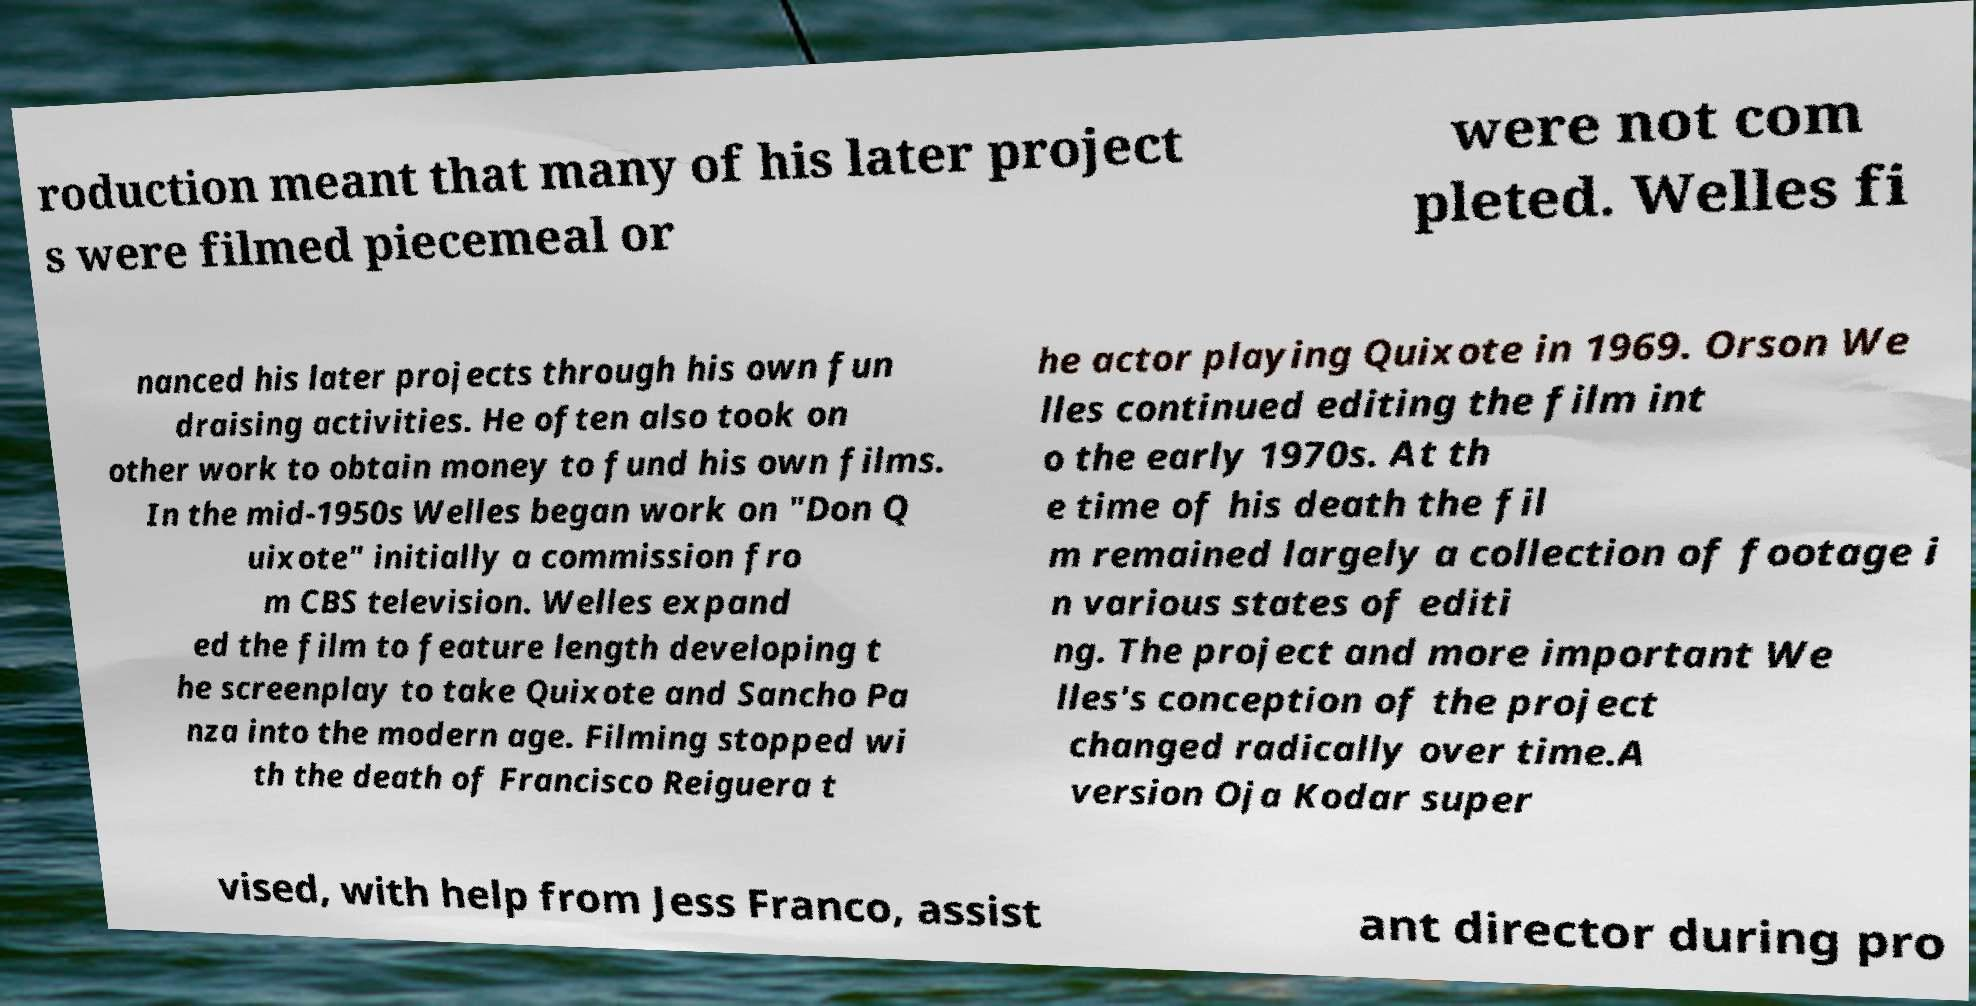Can you read and provide the text displayed in the image?This photo seems to have some interesting text. Can you extract and type it out for me? roduction meant that many of his later project s were filmed piecemeal or were not com pleted. Welles fi nanced his later projects through his own fun draising activities. He often also took on other work to obtain money to fund his own films. In the mid-1950s Welles began work on "Don Q uixote" initially a commission fro m CBS television. Welles expand ed the film to feature length developing t he screenplay to take Quixote and Sancho Pa nza into the modern age. Filming stopped wi th the death of Francisco Reiguera t he actor playing Quixote in 1969. Orson We lles continued editing the film int o the early 1970s. At th e time of his death the fil m remained largely a collection of footage i n various states of editi ng. The project and more important We lles's conception of the project changed radically over time.A version Oja Kodar super vised, with help from Jess Franco, assist ant director during pro 